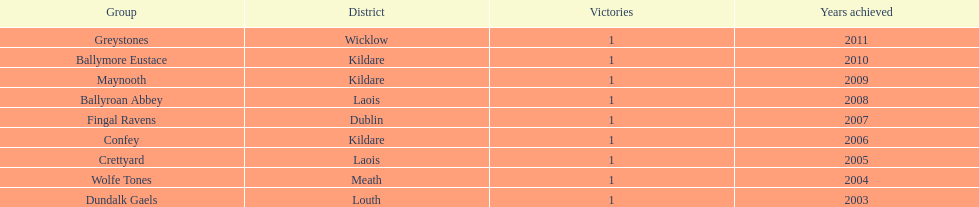What is the cumulative number of wins shown on the chart? 9. Parse the table in full. {'header': ['Group', 'District', 'Victories', 'Years achieved'], 'rows': [['Greystones', 'Wicklow', '1', '2011'], ['Ballymore Eustace', 'Kildare', '1', '2010'], ['Maynooth', 'Kildare', '1', '2009'], ['Ballyroan Abbey', 'Laois', '1', '2008'], ['Fingal Ravens', 'Dublin', '1', '2007'], ['Confey', 'Kildare', '1', '2006'], ['Crettyard', 'Laois', '1', '2005'], ['Wolfe Tones', 'Meath', '1', '2004'], ['Dundalk Gaels', 'Louth', '1', '2003']]} 